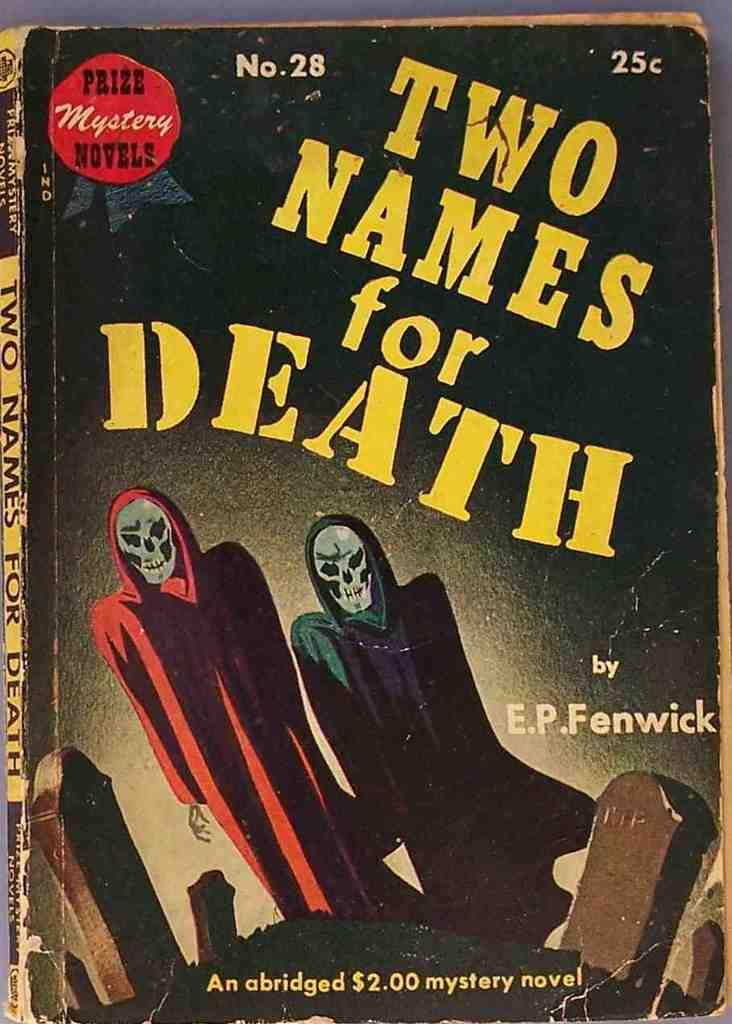<image>
Create a compact narrative representing the image presented. A book titled Two names for Death features two skeletons on the cover. 